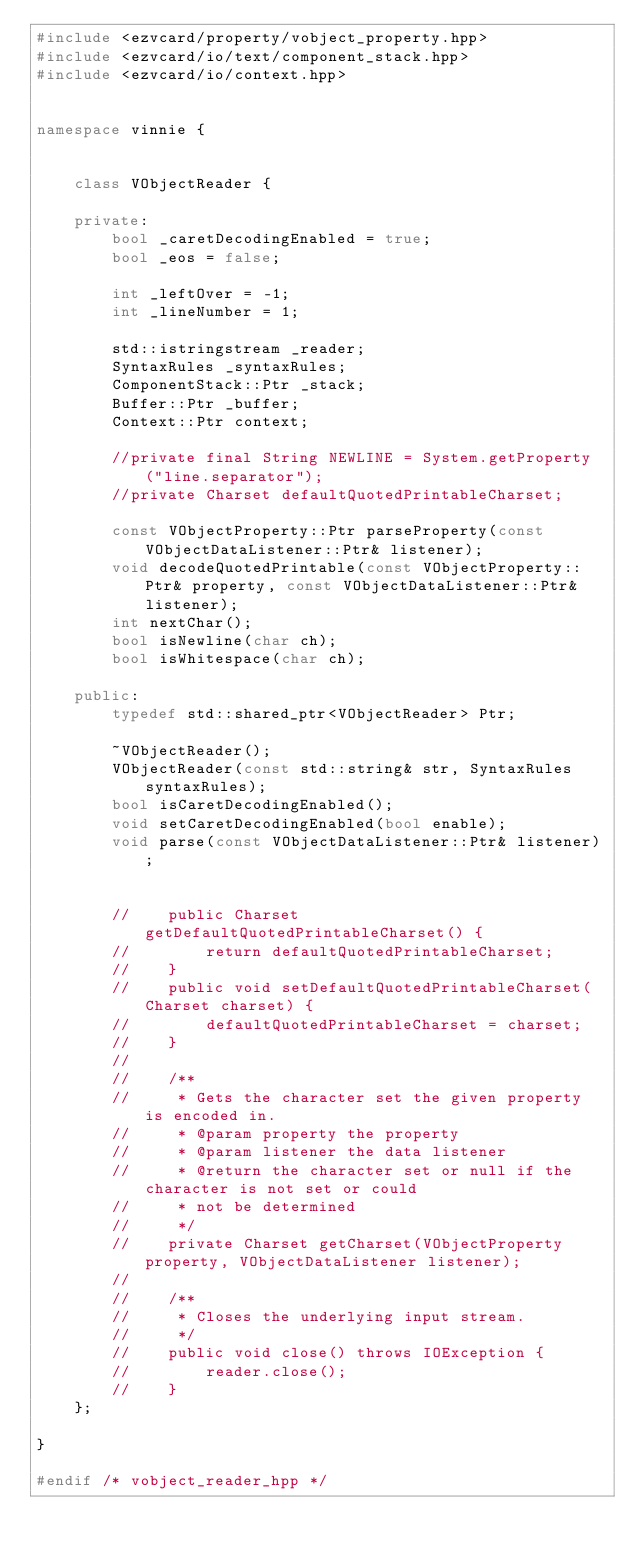Convert code to text. <code><loc_0><loc_0><loc_500><loc_500><_C++_>#include <ezvcard/property/vobject_property.hpp>
#include <ezvcard/io/text/component_stack.hpp>
#include <ezvcard/io/context.hpp>


namespace vinnie {
    
    
    class VObjectReader {
        
    private:
        bool _caretDecodingEnabled = true;
        bool _eos = false;
        
        int _leftOver = -1;
        int _lineNumber = 1;
        
        std::istringstream _reader;
        SyntaxRules _syntaxRules;
        ComponentStack::Ptr _stack;
        Buffer::Ptr _buffer;
        Context::Ptr context;
        
        //private final String NEWLINE = System.getProperty("line.separator");
        //private Charset defaultQuotedPrintableCharset;
        
        const VObjectProperty::Ptr parseProperty(const VObjectDataListener::Ptr& listener);
        void decodeQuotedPrintable(const VObjectProperty::Ptr& property, const VObjectDataListener::Ptr& listener);
        int nextChar();
        bool isNewline(char ch);
        bool isWhitespace(char ch);
        
    public:
        typedef std::shared_ptr<VObjectReader> Ptr;
        
        ~VObjectReader();
        VObjectReader(const std::string& str, SyntaxRules syntaxRules);
        bool isCaretDecodingEnabled();
        void setCaretDecodingEnabled(bool enable);
        void parse(const VObjectDataListener::Ptr& listener);
        
        
        //    public Charset getDefaultQuotedPrintableCharset() {
        //        return defaultQuotedPrintableCharset;
        //    }
        //    public void setDefaultQuotedPrintableCharset(Charset charset) {
        //        defaultQuotedPrintableCharset = charset;
        //    }
        //
        //    /**
        //     * Gets the character set the given property is encoded in.
        //     * @param property the property
        //     * @param listener the data listener
        //     * @return the character set or null if the character is not set or could
        //     * not be determined
        //     */
        //    private Charset getCharset(VObjectProperty property, VObjectDataListener listener);
        //    
        //    /**
        //     * Closes the underlying input stream.
        //     */
        //    public void close() throws IOException {
        //        reader.close();
        //    }
    };
    
}

#endif /* vobject_reader_hpp */
</code> 